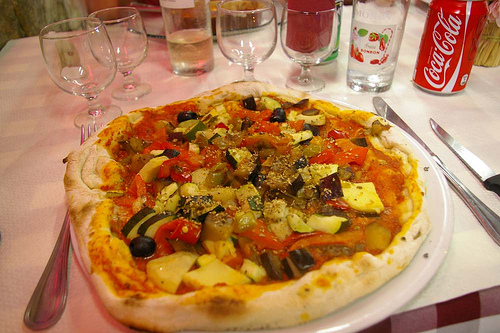In which part is the empty bottle? The empty bottle, once perhaps full of a refreshing drink, now sits quietly on the right part of the image. 